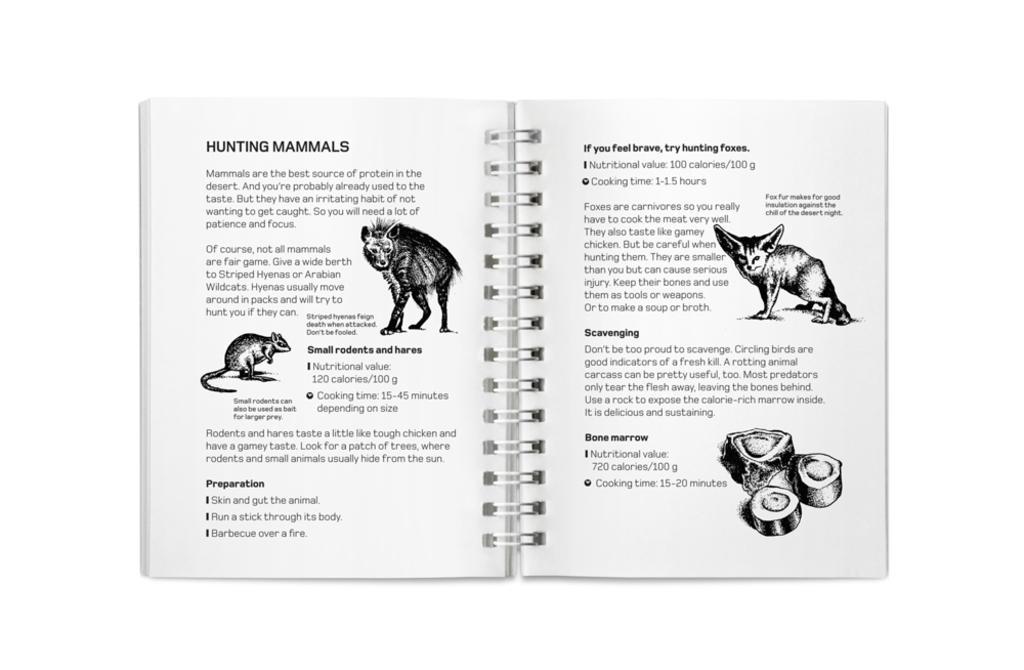What is depicted on the pages of the book in the image? There are pages of a book in the image, with texts and pictures of animals. Can you describe the content of the book? The book contains texts and pictures of animals. What type of business is being conducted in the image? There is no indication of a business being conducted in the image; it features pages of a book with texts and pictures of animals. How does the chin of the animal appear in the image? There is no chin of an animal visible in the image, as it only shows pages of a book with texts and pictures of animals. 